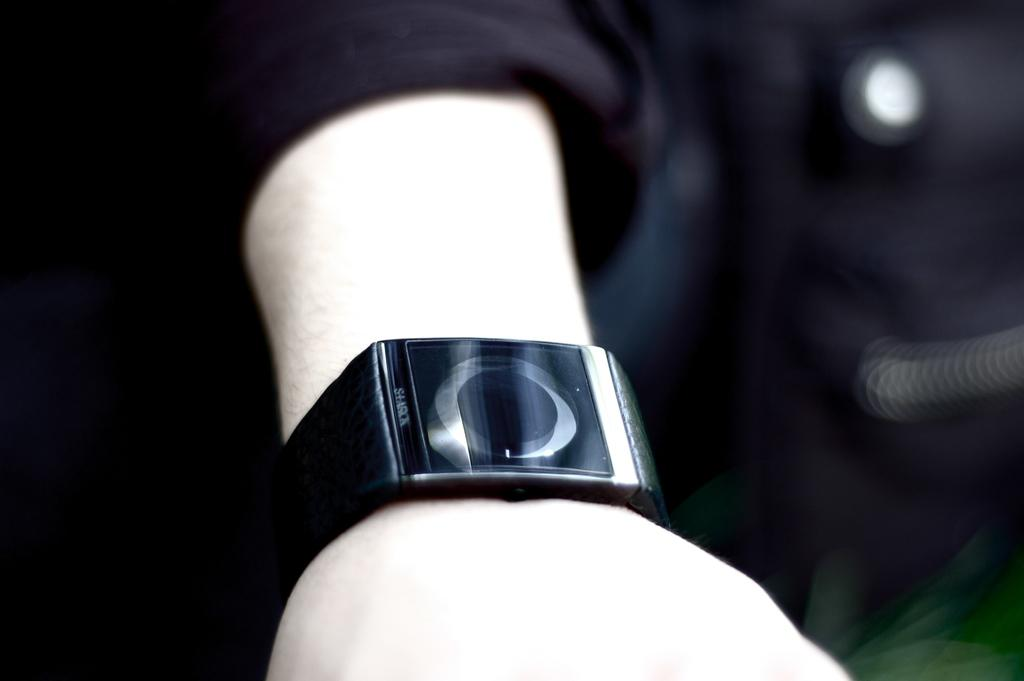What part of a person is visible in the image? There is a person's hand in the image. What accessory is on the person's hand? The person's hand has a black color watch. Can you describe the background of the image? The background of the image is blurred. How many lizards are supporting the person's hand in the image? There are no lizards present in the image, and therefore they cannot be supporting the person's hand. 